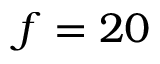<formula> <loc_0><loc_0><loc_500><loc_500>f = 2 0</formula> 